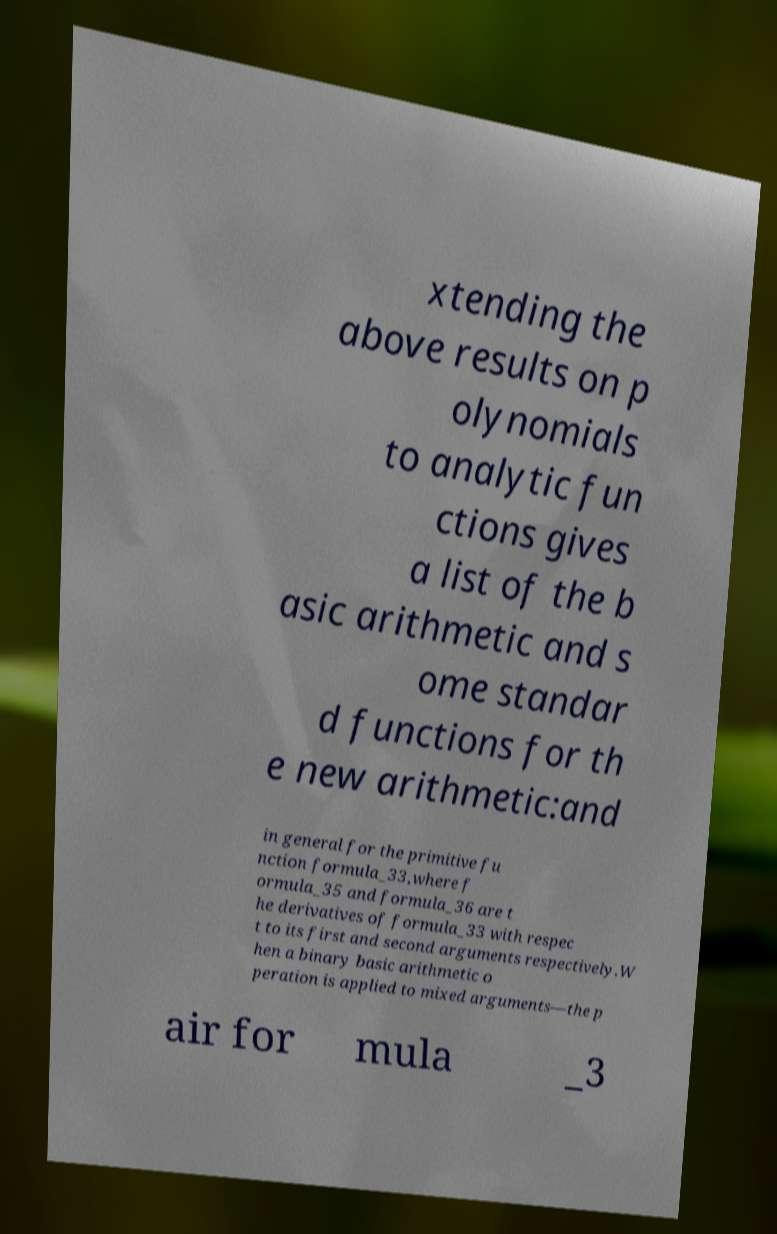Please identify and transcribe the text found in this image. xtending the above results on p olynomials to analytic fun ctions gives a list of the b asic arithmetic and s ome standar d functions for th e new arithmetic:and in general for the primitive fu nction formula_33,where f ormula_35 and formula_36 are t he derivatives of formula_33 with respec t to its first and second arguments respectively.W hen a binary basic arithmetic o peration is applied to mixed arguments—the p air for mula _3 